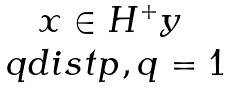<formula> <loc_0><loc_0><loc_500><loc_500>\begin{matrix} x \in H ^ { + } y \\ \ q d i s t { p , q } = 1 \end{matrix}</formula> 